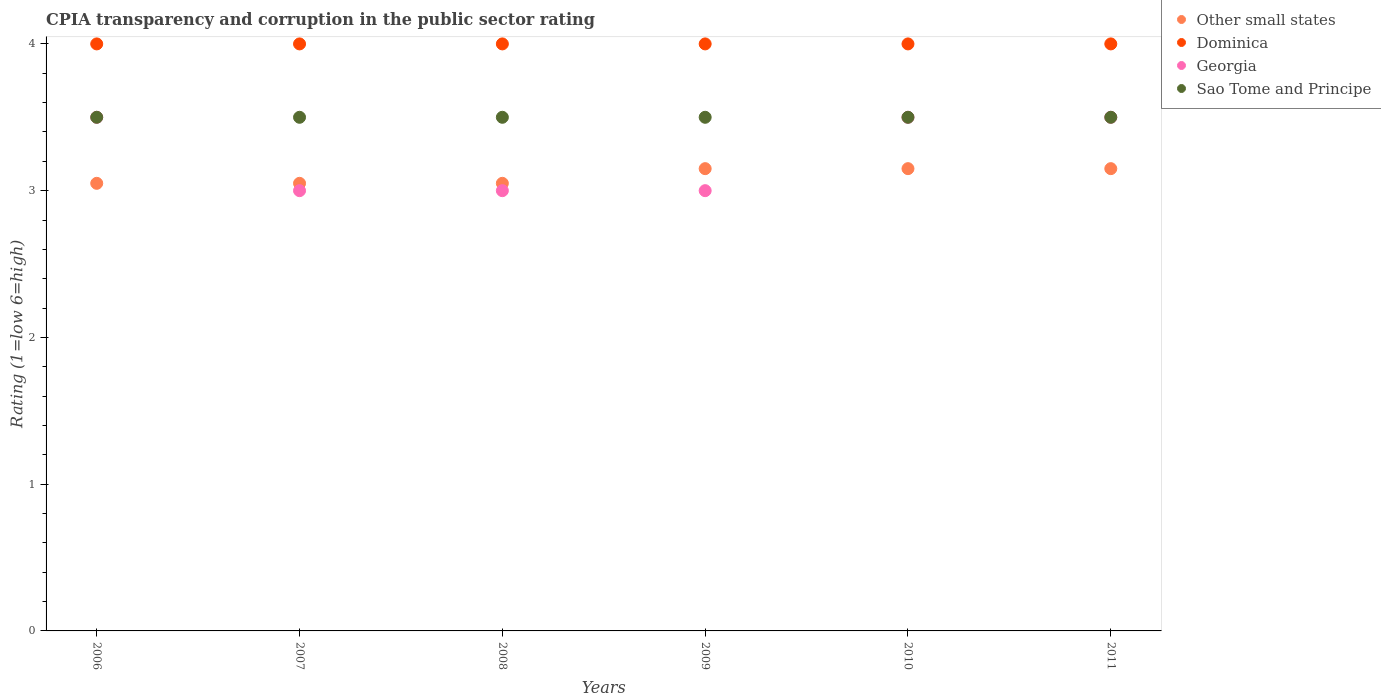How many different coloured dotlines are there?
Offer a terse response. 4. What is the CPIA rating in Other small states in 2008?
Offer a terse response. 3.05. Across all years, what is the maximum CPIA rating in Other small states?
Your answer should be very brief. 3.15. Across all years, what is the minimum CPIA rating in Dominica?
Provide a short and direct response. 4. In which year was the CPIA rating in Other small states maximum?
Make the answer very short. 2009. In which year was the CPIA rating in Other small states minimum?
Provide a succinct answer. 2006. What is the total CPIA rating in Dominica in the graph?
Your response must be concise. 24. What is the average CPIA rating in Other small states per year?
Offer a very short reply. 3.1. In the year 2008, what is the difference between the CPIA rating in Other small states and CPIA rating in Georgia?
Your answer should be very brief. 0.05. Is the CPIA rating in Sao Tome and Principe in 2009 less than that in 2010?
Make the answer very short. No. Is the difference between the CPIA rating in Other small states in 2007 and 2008 greater than the difference between the CPIA rating in Georgia in 2007 and 2008?
Your answer should be very brief. No. What is the difference between the highest and the second highest CPIA rating in Dominica?
Your response must be concise. 0. What is the difference between the highest and the lowest CPIA rating in Sao Tome and Principe?
Give a very brief answer. 0. In how many years, is the CPIA rating in Georgia greater than the average CPIA rating in Georgia taken over all years?
Keep it short and to the point. 3. Is the sum of the CPIA rating in Dominica in 2008 and 2009 greater than the maximum CPIA rating in Georgia across all years?
Ensure brevity in your answer.  Yes. Is it the case that in every year, the sum of the CPIA rating in Dominica and CPIA rating in Other small states  is greater than the sum of CPIA rating in Sao Tome and Principe and CPIA rating in Georgia?
Your response must be concise. Yes. Is it the case that in every year, the sum of the CPIA rating in Dominica and CPIA rating in Sao Tome and Principe  is greater than the CPIA rating in Other small states?
Provide a short and direct response. Yes. Does the CPIA rating in Other small states monotonically increase over the years?
Keep it short and to the point. No. Is the CPIA rating in Georgia strictly less than the CPIA rating in Sao Tome and Principe over the years?
Make the answer very short. No. What is the difference between two consecutive major ticks on the Y-axis?
Your answer should be compact. 1. Are the values on the major ticks of Y-axis written in scientific E-notation?
Offer a terse response. No. Does the graph contain grids?
Keep it short and to the point. No. Where does the legend appear in the graph?
Your answer should be compact. Top right. How many legend labels are there?
Provide a succinct answer. 4. What is the title of the graph?
Your answer should be compact. CPIA transparency and corruption in the public sector rating. What is the label or title of the X-axis?
Offer a very short reply. Years. What is the Rating (1=low 6=high) of Other small states in 2006?
Provide a short and direct response. 3.05. What is the Rating (1=low 6=high) of Dominica in 2006?
Your response must be concise. 4. What is the Rating (1=low 6=high) of Other small states in 2007?
Give a very brief answer. 3.05. What is the Rating (1=low 6=high) in Other small states in 2008?
Offer a terse response. 3.05. What is the Rating (1=low 6=high) of Georgia in 2008?
Make the answer very short. 3. What is the Rating (1=low 6=high) in Sao Tome and Principe in 2008?
Ensure brevity in your answer.  3.5. What is the Rating (1=low 6=high) in Other small states in 2009?
Your answer should be very brief. 3.15. What is the Rating (1=low 6=high) of Georgia in 2009?
Your response must be concise. 3. What is the Rating (1=low 6=high) of Sao Tome and Principe in 2009?
Make the answer very short. 3.5. What is the Rating (1=low 6=high) of Other small states in 2010?
Offer a very short reply. 3.15. What is the Rating (1=low 6=high) of Other small states in 2011?
Give a very brief answer. 3.15. What is the Rating (1=low 6=high) in Georgia in 2011?
Offer a terse response. 3.5. What is the Rating (1=low 6=high) of Sao Tome and Principe in 2011?
Give a very brief answer. 3.5. Across all years, what is the maximum Rating (1=low 6=high) in Other small states?
Your response must be concise. 3.15. Across all years, what is the maximum Rating (1=low 6=high) of Sao Tome and Principe?
Your answer should be very brief. 3.5. Across all years, what is the minimum Rating (1=low 6=high) of Other small states?
Give a very brief answer. 3.05. Across all years, what is the minimum Rating (1=low 6=high) of Dominica?
Offer a very short reply. 4. Across all years, what is the minimum Rating (1=low 6=high) of Sao Tome and Principe?
Make the answer very short. 3.5. What is the total Rating (1=low 6=high) of Other small states in the graph?
Your response must be concise. 18.6. What is the total Rating (1=low 6=high) in Dominica in the graph?
Provide a short and direct response. 24. What is the total Rating (1=low 6=high) in Georgia in the graph?
Your answer should be compact. 19.5. What is the total Rating (1=low 6=high) of Sao Tome and Principe in the graph?
Your answer should be compact. 21. What is the difference between the Rating (1=low 6=high) of Georgia in 2006 and that in 2007?
Provide a short and direct response. 0.5. What is the difference between the Rating (1=low 6=high) of Sao Tome and Principe in 2006 and that in 2007?
Offer a very short reply. 0. What is the difference between the Rating (1=low 6=high) in Dominica in 2006 and that in 2008?
Keep it short and to the point. 0. What is the difference between the Rating (1=low 6=high) in Other small states in 2006 and that in 2011?
Your answer should be compact. -0.1. What is the difference between the Rating (1=low 6=high) in Sao Tome and Principe in 2006 and that in 2011?
Ensure brevity in your answer.  0. What is the difference between the Rating (1=low 6=high) of Other small states in 2007 and that in 2009?
Your answer should be compact. -0.1. What is the difference between the Rating (1=low 6=high) in Georgia in 2007 and that in 2009?
Offer a terse response. 0. What is the difference between the Rating (1=low 6=high) in Sao Tome and Principe in 2007 and that in 2009?
Offer a very short reply. 0. What is the difference between the Rating (1=low 6=high) in Sao Tome and Principe in 2007 and that in 2010?
Your response must be concise. 0. What is the difference between the Rating (1=low 6=high) in Other small states in 2007 and that in 2011?
Ensure brevity in your answer.  -0.1. What is the difference between the Rating (1=low 6=high) in Dominica in 2007 and that in 2011?
Give a very brief answer. 0. What is the difference between the Rating (1=low 6=high) of Sao Tome and Principe in 2007 and that in 2011?
Your response must be concise. 0. What is the difference between the Rating (1=low 6=high) in Sao Tome and Principe in 2008 and that in 2009?
Ensure brevity in your answer.  0. What is the difference between the Rating (1=low 6=high) of Other small states in 2008 and that in 2010?
Provide a succinct answer. -0.1. What is the difference between the Rating (1=low 6=high) of Georgia in 2008 and that in 2010?
Make the answer very short. -0.5. What is the difference between the Rating (1=low 6=high) in Sao Tome and Principe in 2008 and that in 2011?
Your answer should be compact. 0. What is the difference between the Rating (1=low 6=high) in Other small states in 2009 and that in 2010?
Give a very brief answer. 0. What is the difference between the Rating (1=low 6=high) in Dominica in 2009 and that in 2010?
Give a very brief answer. 0. What is the difference between the Rating (1=low 6=high) of Georgia in 2009 and that in 2010?
Your answer should be very brief. -0.5. What is the difference between the Rating (1=low 6=high) of Sao Tome and Principe in 2009 and that in 2010?
Your answer should be very brief. 0. What is the difference between the Rating (1=low 6=high) in Other small states in 2009 and that in 2011?
Your answer should be very brief. 0. What is the difference between the Rating (1=low 6=high) in Dominica in 2009 and that in 2011?
Provide a succinct answer. 0. What is the difference between the Rating (1=low 6=high) in Sao Tome and Principe in 2009 and that in 2011?
Keep it short and to the point. 0. What is the difference between the Rating (1=low 6=high) of Other small states in 2010 and that in 2011?
Ensure brevity in your answer.  0. What is the difference between the Rating (1=low 6=high) in Dominica in 2010 and that in 2011?
Offer a very short reply. 0. What is the difference between the Rating (1=low 6=high) of Georgia in 2010 and that in 2011?
Keep it short and to the point. 0. What is the difference between the Rating (1=low 6=high) of Other small states in 2006 and the Rating (1=low 6=high) of Dominica in 2007?
Provide a short and direct response. -0.95. What is the difference between the Rating (1=low 6=high) in Other small states in 2006 and the Rating (1=low 6=high) in Georgia in 2007?
Your answer should be very brief. 0.05. What is the difference between the Rating (1=low 6=high) in Other small states in 2006 and the Rating (1=low 6=high) in Sao Tome and Principe in 2007?
Your response must be concise. -0.45. What is the difference between the Rating (1=low 6=high) of Dominica in 2006 and the Rating (1=low 6=high) of Sao Tome and Principe in 2007?
Offer a terse response. 0.5. What is the difference between the Rating (1=low 6=high) in Other small states in 2006 and the Rating (1=low 6=high) in Dominica in 2008?
Keep it short and to the point. -0.95. What is the difference between the Rating (1=low 6=high) of Other small states in 2006 and the Rating (1=low 6=high) of Georgia in 2008?
Offer a terse response. 0.05. What is the difference between the Rating (1=low 6=high) in Other small states in 2006 and the Rating (1=low 6=high) in Sao Tome and Principe in 2008?
Provide a short and direct response. -0.45. What is the difference between the Rating (1=low 6=high) of Dominica in 2006 and the Rating (1=low 6=high) of Sao Tome and Principe in 2008?
Offer a terse response. 0.5. What is the difference between the Rating (1=low 6=high) of Georgia in 2006 and the Rating (1=low 6=high) of Sao Tome and Principe in 2008?
Your answer should be very brief. 0. What is the difference between the Rating (1=low 6=high) of Other small states in 2006 and the Rating (1=low 6=high) of Dominica in 2009?
Your response must be concise. -0.95. What is the difference between the Rating (1=low 6=high) of Other small states in 2006 and the Rating (1=low 6=high) of Georgia in 2009?
Make the answer very short. 0.05. What is the difference between the Rating (1=low 6=high) of Other small states in 2006 and the Rating (1=low 6=high) of Sao Tome and Principe in 2009?
Provide a succinct answer. -0.45. What is the difference between the Rating (1=low 6=high) of Dominica in 2006 and the Rating (1=low 6=high) of Georgia in 2009?
Offer a terse response. 1. What is the difference between the Rating (1=low 6=high) in Other small states in 2006 and the Rating (1=low 6=high) in Dominica in 2010?
Make the answer very short. -0.95. What is the difference between the Rating (1=low 6=high) in Other small states in 2006 and the Rating (1=low 6=high) in Georgia in 2010?
Provide a succinct answer. -0.45. What is the difference between the Rating (1=low 6=high) in Other small states in 2006 and the Rating (1=low 6=high) in Sao Tome and Principe in 2010?
Provide a short and direct response. -0.45. What is the difference between the Rating (1=low 6=high) in Georgia in 2006 and the Rating (1=low 6=high) in Sao Tome and Principe in 2010?
Provide a succinct answer. 0. What is the difference between the Rating (1=low 6=high) of Other small states in 2006 and the Rating (1=low 6=high) of Dominica in 2011?
Ensure brevity in your answer.  -0.95. What is the difference between the Rating (1=low 6=high) in Other small states in 2006 and the Rating (1=low 6=high) in Georgia in 2011?
Offer a very short reply. -0.45. What is the difference between the Rating (1=low 6=high) in Other small states in 2006 and the Rating (1=low 6=high) in Sao Tome and Principe in 2011?
Keep it short and to the point. -0.45. What is the difference between the Rating (1=low 6=high) of Georgia in 2006 and the Rating (1=low 6=high) of Sao Tome and Principe in 2011?
Your response must be concise. 0. What is the difference between the Rating (1=low 6=high) in Other small states in 2007 and the Rating (1=low 6=high) in Dominica in 2008?
Give a very brief answer. -0.95. What is the difference between the Rating (1=low 6=high) in Other small states in 2007 and the Rating (1=low 6=high) in Sao Tome and Principe in 2008?
Ensure brevity in your answer.  -0.45. What is the difference between the Rating (1=low 6=high) in Other small states in 2007 and the Rating (1=low 6=high) in Dominica in 2009?
Provide a succinct answer. -0.95. What is the difference between the Rating (1=low 6=high) of Other small states in 2007 and the Rating (1=low 6=high) of Sao Tome and Principe in 2009?
Provide a short and direct response. -0.45. What is the difference between the Rating (1=low 6=high) of Dominica in 2007 and the Rating (1=low 6=high) of Sao Tome and Principe in 2009?
Offer a terse response. 0.5. What is the difference between the Rating (1=low 6=high) in Other small states in 2007 and the Rating (1=low 6=high) in Dominica in 2010?
Make the answer very short. -0.95. What is the difference between the Rating (1=low 6=high) of Other small states in 2007 and the Rating (1=low 6=high) of Georgia in 2010?
Offer a very short reply. -0.45. What is the difference between the Rating (1=low 6=high) of Other small states in 2007 and the Rating (1=low 6=high) of Sao Tome and Principe in 2010?
Give a very brief answer. -0.45. What is the difference between the Rating (1=low 6=high) in Dominica in 2007 and the Rating (1=low 6=high) in Georgia in 2010?
Offer a terse response. 0.5. What is the difference between the Rating (1=low 6=high) of Dominica in 2007 and the Rating (1=low 6=high) of Sao Tome and Principe in 2010?
Offer a very short reply. 0.5. What is the difference between the Rating (1=low 6=high) in Georgia in 2007 and the Rating (1=low 6=high) in Sao Tome and Principe in 2010?
Give a very brief answer. -0.5. What is the difference between the Rating (1=low 6=high) of Other small states in 2007 and the Rating (1=low 6=high) of Dominica in 2011?
Keep it short and to the point. -0.95. What is the difference between the Rating (1=low 6=high) in Other small states in 2007 and the Rating (1=low 6=high) in Georgia in 2011?
Keep it short and to the point. -0.45. What is the difference between the Rating (1=low 6=high) of Other small states in 2007 and the Rating (1=low 6=high) of Sao Tome and Principe in 2011?
Ensure brevity in your answer.  -0.45. What is the difference between the Rating (1=low 6=high) in Dominica in 2007 and the Rating (1=low 6=high) in Georgia in 2011?
Provide a short and direct response. 0.5. What is the difference between the Rating (1=low 6=high) of Dominica in 2007 and the Rating (1=low 6=high) of Sao Tome and Principe in 2011?
Keep it short and to the point. 0.5. What is the difference between the Rating (1=low 6=high) of Other small states in 2008 and the Rating (1=low 6=high) of Dominica in 2009?
Make the answer very short. -0.95. What is the difference between the Rating (1=low 6=high) of Other small states in 2008 and the Rating (1=low 6=high) of Georgia in 2009?
Give a very brief answer. 0.05. What is the difference between the Rating (1=low 6=high) in Other small states in 2008 and the Rating (1=low 6=high) in Sao Tome and Principe in 2009?
Your answer should be very brief. -0.45. What is the difference between the Rating (1=low 6=high) in Dominica in 2008 and the Rating (1=low 6=high) in Sao Tome and Principe in 2009?
Make the answer very short. 0.5. What is the difference between the Rating (1=low 6=high) in Other small states in 2008 and the Rating (1=low 6=high) in Dominica in 2010?
Make the answer very short. -0.95. What is the difference between the Rating (1=low 6=high) of Other small states in 2008 and the Rating (1=low 6=high) of Georgia in 2010?
Offer a terse response. -0.45. What is the difference between the Rating (1=low 6=high) of Other small states in 2008 and the Rating (1=low 6=high) of Sao Tome and Principe in 2010?
Give a very brief answer. -0.45. What is the difference between the Rating (1=low 6=high) of Dominica in 2008 and the Rating (1=low 6=high) of Georgia in 2010?
Your answer should be compact. 0.5. What is the difference between the Rating (1=low 6=high) of Other small states in 2008 and the Rating (1=low 6=high) of Dominica in 2011?
Give a very brief answer. -0.95. What is the difference between the Rating (1=low 6=high) in Other small states in 2008 and the Rating (1=low 6=high) in Georgia in 2011?
Offer a very short reply. -0.45. What is the difference between the Rating (1=low 6=high) in Other small states in 2008 and the Rating (1=low 6=high) in Sao Tome and Principe in 2011?
Your answer should be compact. -0.45. What is the difference between the Rating (1=low 6=high) of Other small states in 2009 and the Rating (1=low 6=high) of Dominica in 2010?
Provide a short and direct response. -0.85. What is the difference between the Rating (1=low 6=high) of Other small states in 2009 and the Rating (1=low 6=high) of Georgia in 2010?
Ensure brevity in your answer.  -0.35. What is the difference between the Rating (1=low 6=high) of Other small states in 2009 and the Rating (1=low 6=high) of Sao Tome and Principe in 2010?
Ensure brevity in your answer.  -0.35. What is the difference between the Rating (1=low 6=high) of Dominica in 2009 and the Rating (1=low 6=high) of Georgia in 2010?
Ensure brevity in your answer.  0.5. What is the difference between the Rating (1=low 6=high) of Other small states in 2009 and the Rating (1=low 6=high) of Dominica in 2011?
Offer a very short reply. -0.85. What is the difference between the Rating (1=low 6=high) in Other small states in 2009 and the Rating (1=low 6=high) in Georgia in 2011?
Your answer should be compact. -0.35. What is the difference between the Rating (1=low 6=high) of Other small states in 2009 and the Rating (1=low 6=high) of Sao Tome and Principe in 2011?
Your answer should be very brief. -0.35. What is the difference between the Rating (1=low 6=high) in Other small states in 2010 and the Rating (1=low 6=high) in Dominica in 2011?
Keep it short and to the point. -0.85. What is the difference between the Rating (1=low 6=high) of Other small states in 2010 and the Rating (1=low 6=high) of Georgia in 2011?
Offer a very short reply. -0.35. What is the difference between the Rating (1=low 6=high) in Other small states in 2010 and the Rating (1=low 6=high) in Sao Tome and Principe in 2011?
Offer a terse response. -0.35. What is the difference between the Rating (1=low 6=high) of Dominica in 2010 and the Rating (1=low 6=high) of Sao Tome and Principe in 2011?
Provide a short and direct response. 0.5. What is the difference between the Rating (1=low 6=high) of Georgia in 2010 and the Rating (1=low 6=high) of Sao Tome and Principe in 2011?
Make the answer very short. 0. What is the average Rating (1=low 6=high) in Other small states per year?
Provide a succinct answer. 3.1. What is the average Rating (1=low 6=high) in Dominica per year?
Ensure brevity in your answer.  4. What is the average Rating (1=low 6=high) in Georgia per year?
Offer a very short reply. 3.25. In the year 2006, what is the difference between the Rating (1=low 6=high) of Other small states and Rating (1=low 6=high) of Dominica?
Offer a terse response. -0.95. In the year 2006, what is the difference between the Rating (1=low 6=high) in Other small states and Rating (1=low 6=high) in Georgia?
Make the answer very short. -0.45. In the year 2006, what is the difference between the Rating (1=low 6=high) of Other small states and Rating (1=low 6=high) of Sao Tome and Principe?
Offer a very short reply. -0.45. In the year 2007, what is the difference between the Rating (1=low 6=high) of Other small states and Rating (1=low 6=high) of Dominica?
Provide a succinct answer. -0.95. In the year 2007, what is the difference between the Rating (1=low 6=high) of Other small states and Rating (1=low 6=high) of Georgia?
Your answer should be very brief. 0.05. In the year 2007, what is the difference between the Rating (1=low 6=high) in Other small states and Rating (1=low 6=high) in Sao Tome and Principe?
Your response must be concise. -0.45. In the year 2007, what is the difference between the Rating (1=low 6=high) of Dominica and Rating (1=low 6=high) of Sao Tome and Principe?
Your response must be concise. 0.5. In the year 2008, what is the difference between the Rating (1=low 6=high) of Other small states and Rating (1=low 6=high) of Dominica?
Provide a succinct answer. -0.95. In the year 2008, what is the difference between the Rating (1=low 6=high) in Other small states and Rating (1=low 6=high) in Sao Tome and Principe?
Offer a very short reply. -0.45. In the year 2008, what is the difference between the Rating (1=low 6=high) in Dominica and Rating (1=low 6=high) in Georgia?
Make the answer very short. 1. In the year 2008, what is the difference between the Rating (1=low 6=high) of Georgia and Rating (1=low 6=high) of Sao Tome and Principe?
Give a very brief answer. -0.5. In the year 2009, what is the difference between the Rating (1=low 6=high) in Other small states and Rating (1=low 6=high) in Dominica?
Your answer should be compact. -0.85. In the year 2009, what is the difference between the Rating (1=low 6=high) of Other small states and Rating (1=low 6=high) of Sao Tome and Principe?
Give a very brief answer. -0.35. In the year 2009, what is the difference between the Rating (1=low 6=high) of Dominica and Rating (1=low 6=high) of Sao Tome and Principe?
Your answer should be compact. 0.5. In the year 2009, what is the difference between the Rating (1=low 6=high) of Georgia and Rating (1=low 6=high) of Sao Tome and Principe?
Offer a very short reply. -0.5. In the year 2010, what is the difference between the Rating (1=low 6=high) in Other small states and Rating (1=low 6=high) in Dominica?
Give a very brief answer. -0.85. In the year 2010, what is the difference between the Rating (1=low 6=high) in Other small states and Rating (1=low 6=high) in Georgia?
Your answer should be compact. -0.35. In the year 2010, what is the difference between the Rating (1=low 6=high) in Other small states and Rating (1=low 6=high) in Sao Tome and Principe?
Provide a short and direct response. -0.35. In the year 2010, what is the difference between the Rating (1=low 6=high) in Dominica and Rating (1=low 6=high) in Georgia?
Keep it short and to the point. 0.5. In the year 2011, what is the difference between the Rating (1=low 6=high) of Other small states and Rating (1=low 6=high) of Dominica?
Your response must be concise. -0.85. In the year 2011, what is the difference between the Rating (1=low 6=high) in Other small states and Rating (1=low 6=high) in Georgia?
Your answer should be compact. -0.35. In the year 2011, what is the difference between the Rating (1=low 6=high) in Other small states and Rating (1=low 6=high) in Sao Tome and Principe?
Your answer should be compact. -0.35. In the year 2011, what is the difference between the Rating (1=low 6=high) in Dominica and Rating (1=low 6=high) in Georgia?
Your response must be concise. 0.5. In the year 2011, what is the difference between the Rating (1=low 6=high) of Dominica and Rating (1=low 6=high) of Sao Tome and Principe?
Offer a terse response. 0.5. In the year 2011, what is the difference between the Rating (1=low 6=high) of Georgia and Rating (1=low 6=high) of Sao Tome and Principe?
Offer a very short reply. 0. What is the ratio of the Rating (1=low 6=high) in Dominica in 2006 to that in 2007?
Provide a succinct answer. 1. What is the ratio of the Rating (1=low 6=high) of Sao Tome and Principe in 2006 to that in 2007?
Offer a terse response. 1. What is the ratio of the Rating (1=low 6=high) of Other small states in 2006 to that in 2008?
Offer a terse response. 1. What is the ratio of the Rating (1=low 6=high) in Dominica in 2006 to that in 2008?
Give a very brief answer. 1. What is the ratio of the Rating (1=low 6=high) of Georgia in 2006 to that in 2008?
Offer a very short reply. 1.17. What is the ratio of the Rating (1=low 6=high) of Other small states in 2006 to that in 2009?
Give a very brief answer. 0.97. What is the ratio of the Rating (1=low 6=high) in Sao Tome and Principe in 2006 to that in 2009?
Provide a succinct answer. 1. What is the ratio of the Rating (1=low 6=high) of Other small states in 2006 to that in 2010?
Provide a succinct answer. 0.97. What is the ratio of the Rating (1=low 6=high) in Dominica in 2006 to that in 2010?
Provide a short and direct response. 1. What is the ratio of the Rating (1=low 6=high) of Other small states in 2006 to that in 2011?
Provide a short and direct response. 0.97. What is the ratio of the Rating (1=low 6=high) in Georgia in 2006 to that in 2011?
Give a very brief answer. 1. What is the ratio of the Rating (1=low 6=high) in Sao Tome and Principe in 2006 to that in 2011?
Offer a very short reply. 1. What is the ratio of the Rating (1=low 6=high) in Other small states in 2007 to that in 2008?
Your answer should be compact. 1. What is the ratio of the Rating (1=low 6=high) in Georgia in 2007 to that in 2008?
Ensure brevity in your answer.  1. What is the ratio of the Rating (1=low 6=high) of Other small states in 2007 to that in 2009?
Your answer should be compact. 0.97. What is the ratio of the Rating (1=low 6=high) of Dominica in 2007 to that in 2009?
Offer a terse response. 1. What is the ratio of the Rating (1=low 6=high) of Georgia in 2007 to that in 2009?
Ensure brevity in your answer.  1. What is the ratio of the Rating (1=low 6=high) in Other small states in 2007 to that in 2010?
Ensure brevity in your answer.  0.97. What is the ratio of the Rating (1=low 6=high) of Dominica in 2007 to that in 2010?
Your response must be concise. 1. What is the ratio of the Rating (1=low 6=high) of Other small states in 2007 to that in 2011?
Your answer should be compact. 0.97. What is the ratio of the Rating (1=low 6=high) of Dominica in 2007 to that in 2011?
Offer a terse response. 1. What is the ratio of the Rating (1=low 6=high) in Georgia in 2007 to that in 2011?
Your response must be concise. 0.86. What is the ratio of the Rating (1=low 6=high) in Other small states in 2008 to that in 2009?
Provide a succinct answer. 0.97. What is the ratio of the Rating (1=low 6=high) in Sao Tome and Principe in 2008 to that in 2009?
Provide a short and direct response. 1. What is the ratio of the Rating (1=low 6=high) in Other small states in 2008 to that in 2010?
Keep it short and to the point. 0.97. What is the ratio of the Rating (1=low 6=high) in Georgia in 2008 to that in 2010?
Your answer should be compact. 0.86. What is the ratio of the Rating (1=low 6=high) of Sao Tome and Principe in 2008 to that in 2010?
Offer a terse response. 1. What is the ratio of the Rating (1=low 6=high) of Other small states in 2008 to that in 2011?
Provide a short and direct response. 0.97. What is the ratio of the Rating (1=low 6=high) in Dominica in 2008 to that in 2011?
Your response must be concise. 1. What is the ratio of the Rating (1=low 6=high) in Sao Tome and Principe in 2008 to that in 2011?
Provide a succinct answer. 1. What is the ratio of the Rating (1=low 6=high) in Dominica in 2009 to that in 2010?
Ensure brevity in your answer.  1. What is the ratio of the Rating (1=low 6=high) in Georgia in 2009 to that in 2010?
Your answer should be very brief. 0.86. What is the ratio of the Rating (1=low 6=high) in Dominica in 2009 to that in 2011?
Keep it short and to the point. 1. What is the ratio of the Rating (1=low 6=high) of Georgia in 2009 to that in 2011?
Provide a short and direct response. 0.86. What is the ratio of the Rating (1=low 6=high) in Sao Tome and Principe in 2009 to that in 2011?
Make the answer very short. 1. What is the ratio of the Rating (1=low 6=high) in Other small states in 2010 to that in 2011?
Give a very brief answer. 1. What is the ratio of the Rating (1=low 6=high) of Dominica in 2010 to that in 2011?
Offer a very short reply. 1. What is the ratio of the Rating (1=low 6=high) in Georgia in 2010 to that in 2011?
Give a very brief answer. 1. What is the difference between the highest and the second highest Rating (1=low 6=high) of Other small states?
Provide a succinct answer. 0. What is the difference between the highest and the second highest Rating (1=low 6=high) of Dominica?
Ensure brevity in your answer.  0. What is the difference between the highest and the lowest Rating (1=low 6=high) in Other small states?
Offer a terse response. 0.1. 